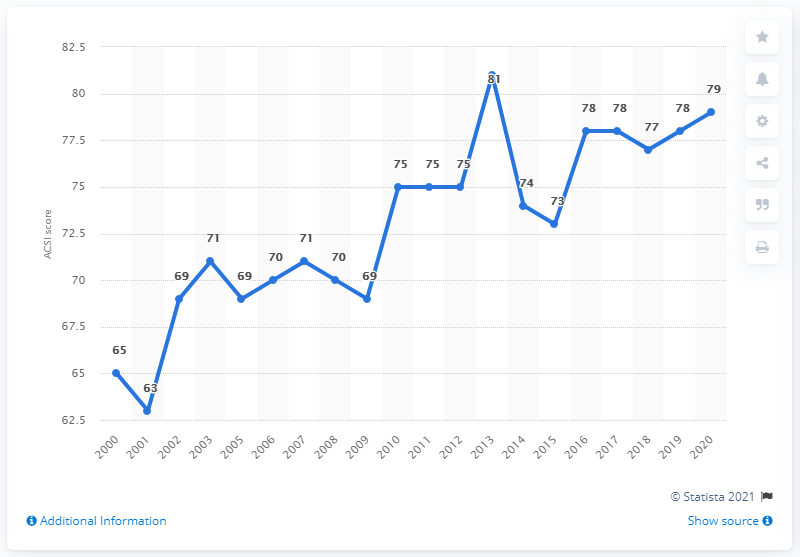Point out several critical features in this image. The American Customer Satisfaction Index (ACSI) scores for KFC restaurants in the United States between 2009 and 2010 showed a significant difference. Specifically, the ACSI scores for KFC restaurants in 2010 were higher than those in 2009, with a difference of 6 points. The American Customer Satisfaction Index (ACSI) scores of KFC restaurants in the United States reached a highest value of 81 during the period between 2000 and 2020. 